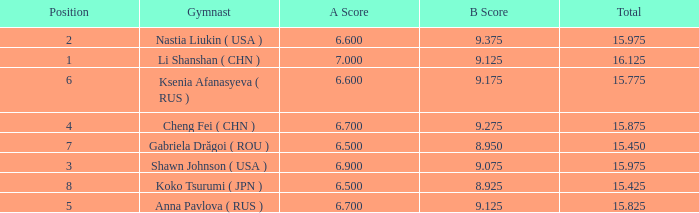What's the total that the position is less than 1? None. 